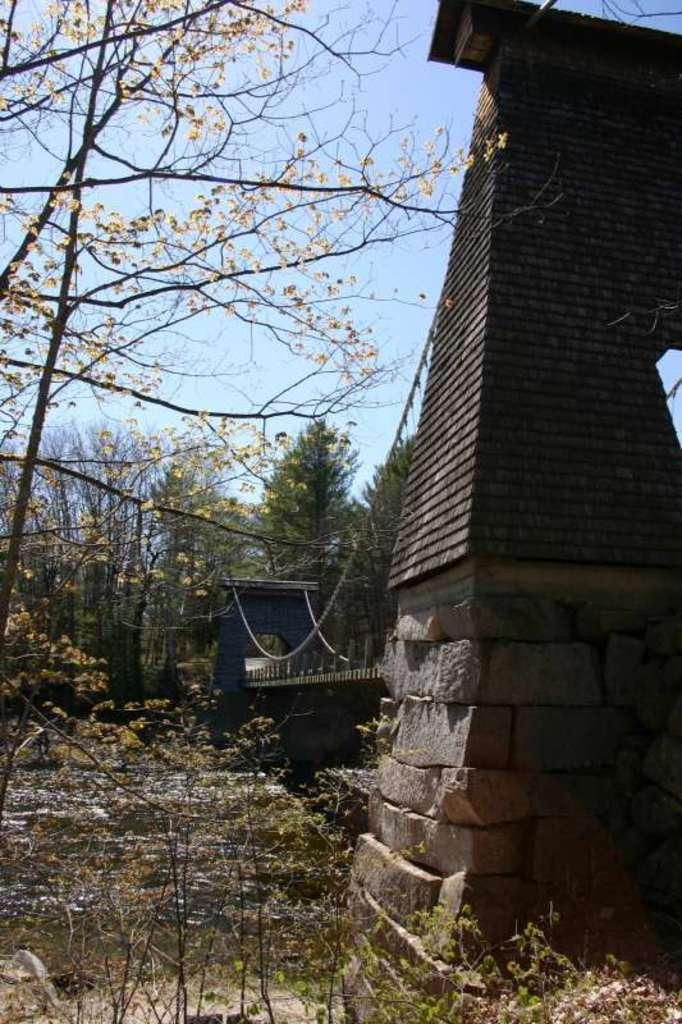What structure can be seen in the right corner of the image? There is a bridge in the right corner of the image. What is under the bridge? There is water under the bridge. What can be seen in the background of the image? There are trees in the background of the image. Can you see a fight happening on the bridge in the image? There is no fight depicted on the bridge in the image. What type of cannon is present on the bridge in the image? There is no cannon present on the bridge or in the image. 